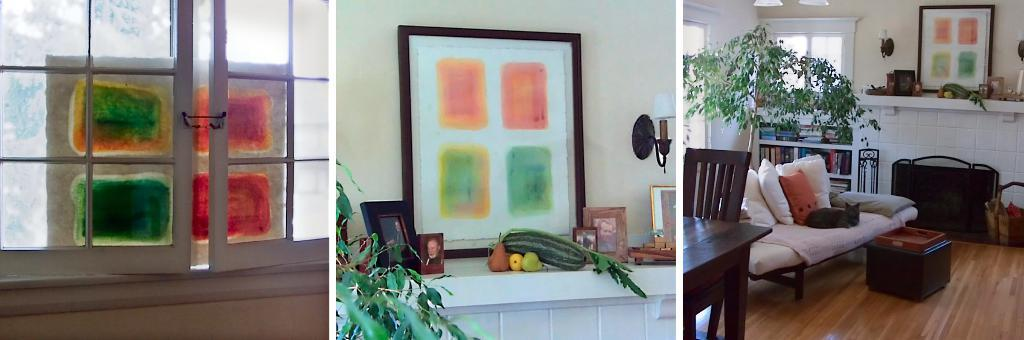What type of openings can be seen in the image? There are windows in the image. What items are used for displaying photographs in the image? There are photo frames in the image. What type of food items are visible in the image? There are vegetables in the image. What type of furniture is present in the image? There is a sofa in the image. What type of items are used for reading and learning in the image? There are books in the image. What type of living organism is present in the image? There is a plant in the image. How many dogs are sitting on the sofa in the image? There are no dogs present in the image; it only features a sofa, books, a plant, and other items. What type of beverage is being served in the passenger's glass in the image? There is no passenger or glass with a beverage present in the image. 